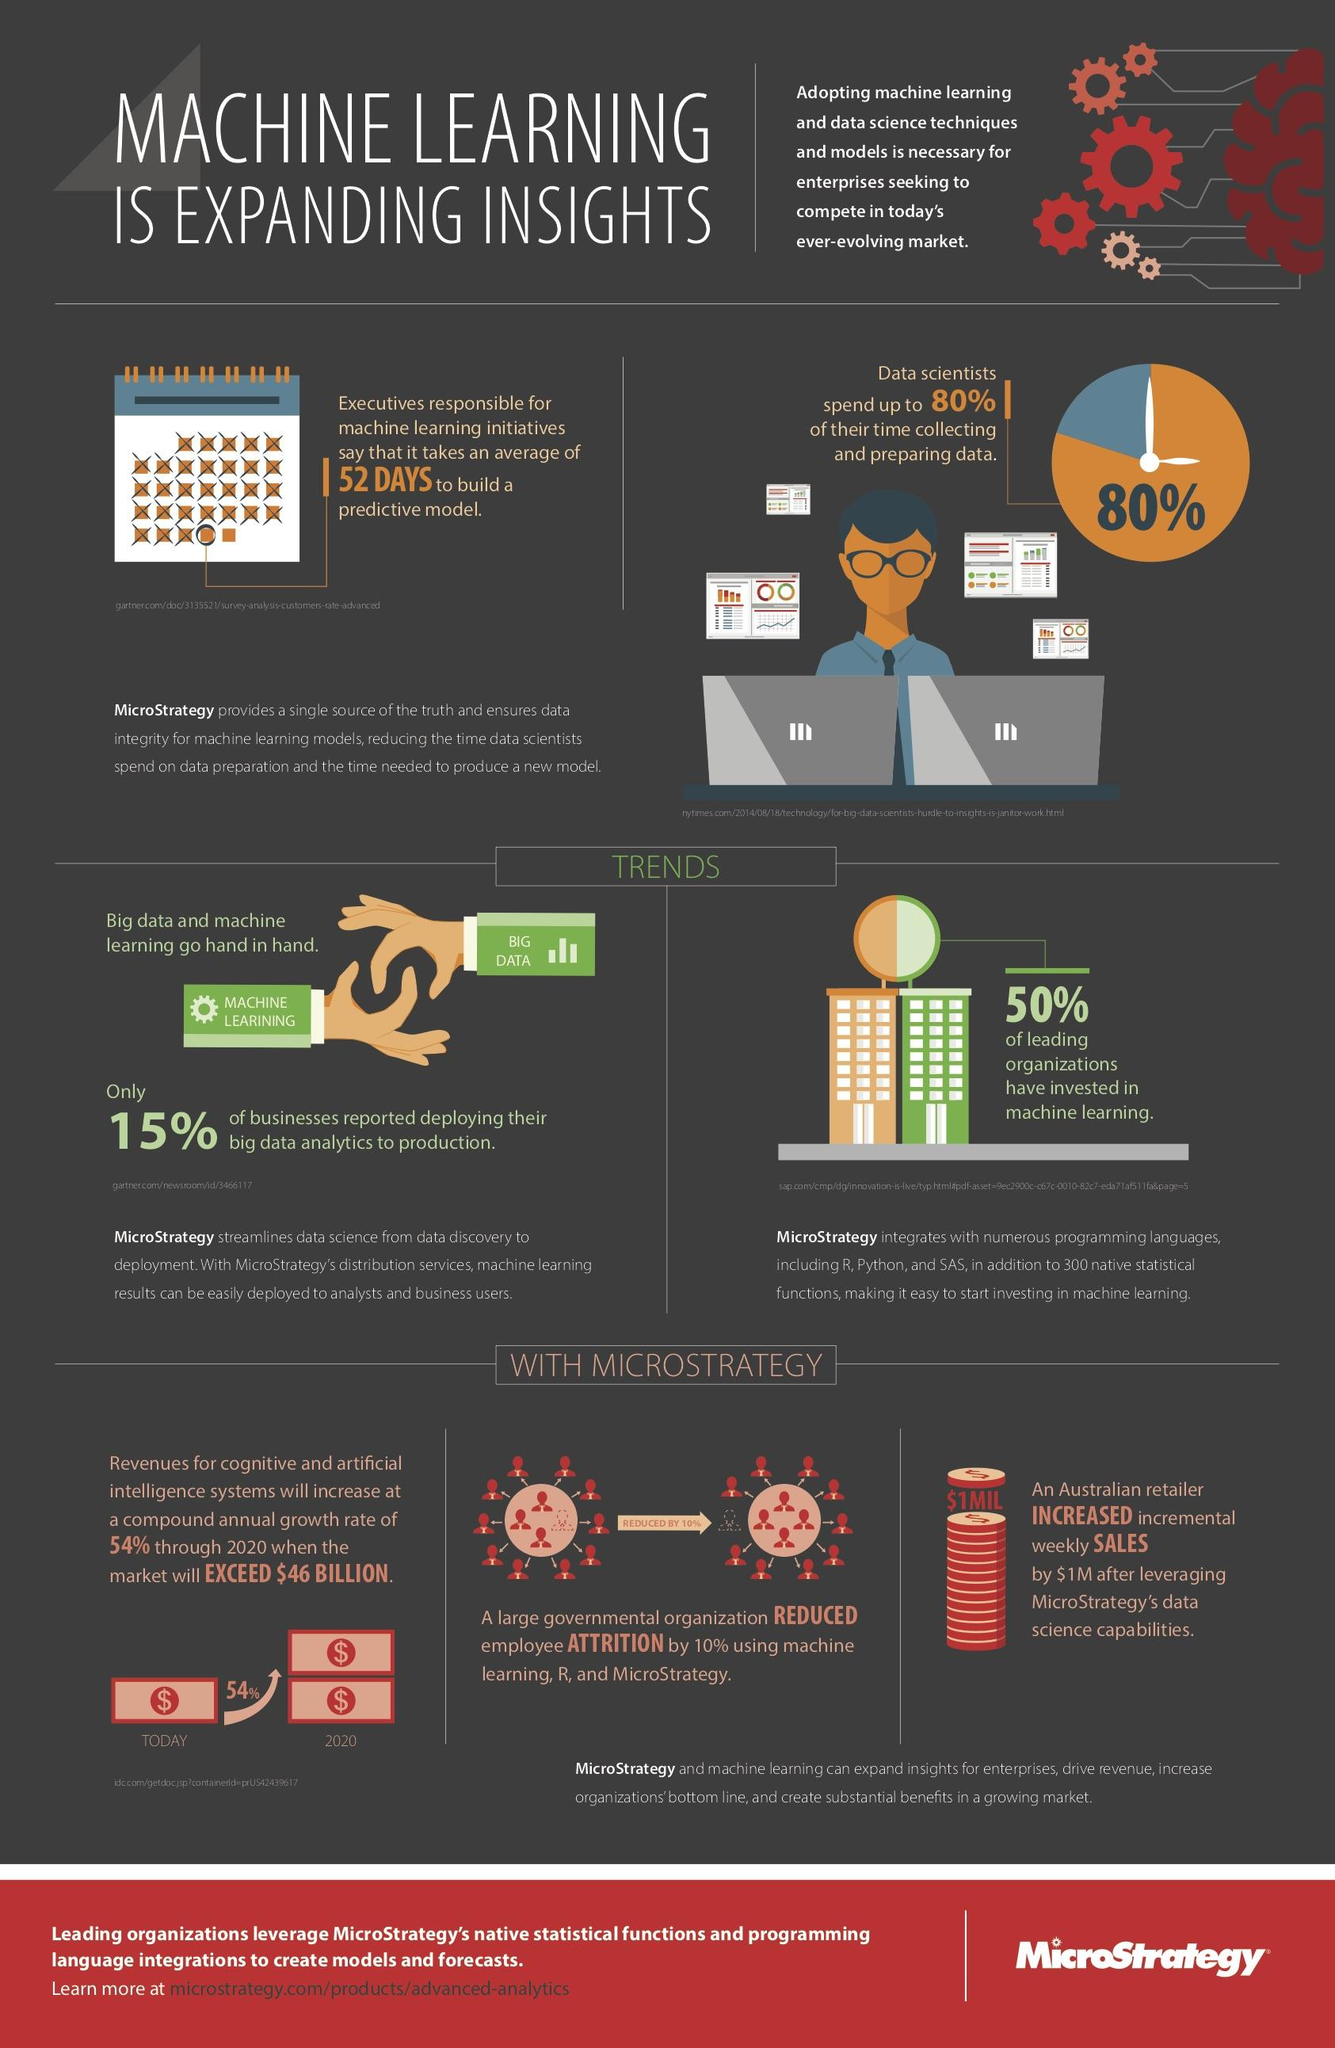Mention a couple of crucial points in this snapshot. According to a recent survey, 85% of businesses are not deploying their big data analytics to production. According to the data scientist, approximately 20% of their time is not dedicated to collecting and preparing data. 